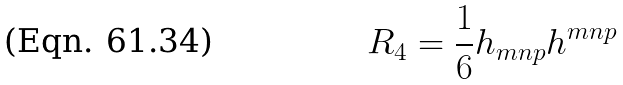<formula> <loc_0><loc_0><loc_500><loc_500>R _ { 4 } = \frac { 1 } { 6 } h _ { m n p } h ^ { m n p }</formula> 